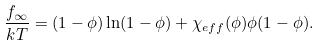Convert formula to latex. <formula><loc_0><loc_0><loc_500><loc_500>\frac { f _ { \infty } } { k T } = ( 1 - \phi ) \ln ( 1 - \phi ) + \chi _ { e f f } ( \phi ) \phi ( 1 - \phi ) .</formula> 